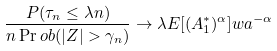Convert formula to latex. <formula><loc_0><loc_0><loc_500><loc_500>\frac { P ( \tau _ { n } \leq \lambda n ) } { n \Pr o b ( | Z | > \gamma _ { n } ) } \to \lambda E [ ( A ^ { * } _ { 1 } ) ^ { \alpha } ] w a ^ { - \alpha }</formula> 